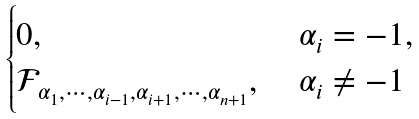<formula> <loc_0><loc_0><loc_500><loc_500>\begin{cases} 0 , & \alpha _ { i } = - 1 , \\ \mathcal { F } _ { \alpha _ { 1 } , \cdots , \alpha _ { i - 1 } , \alpha _ { i + 1 } , \cdots , \alpha _ { n + 1 } } , \ & \alpha _ { i } \not = - 1 \end{cases}</formula> 